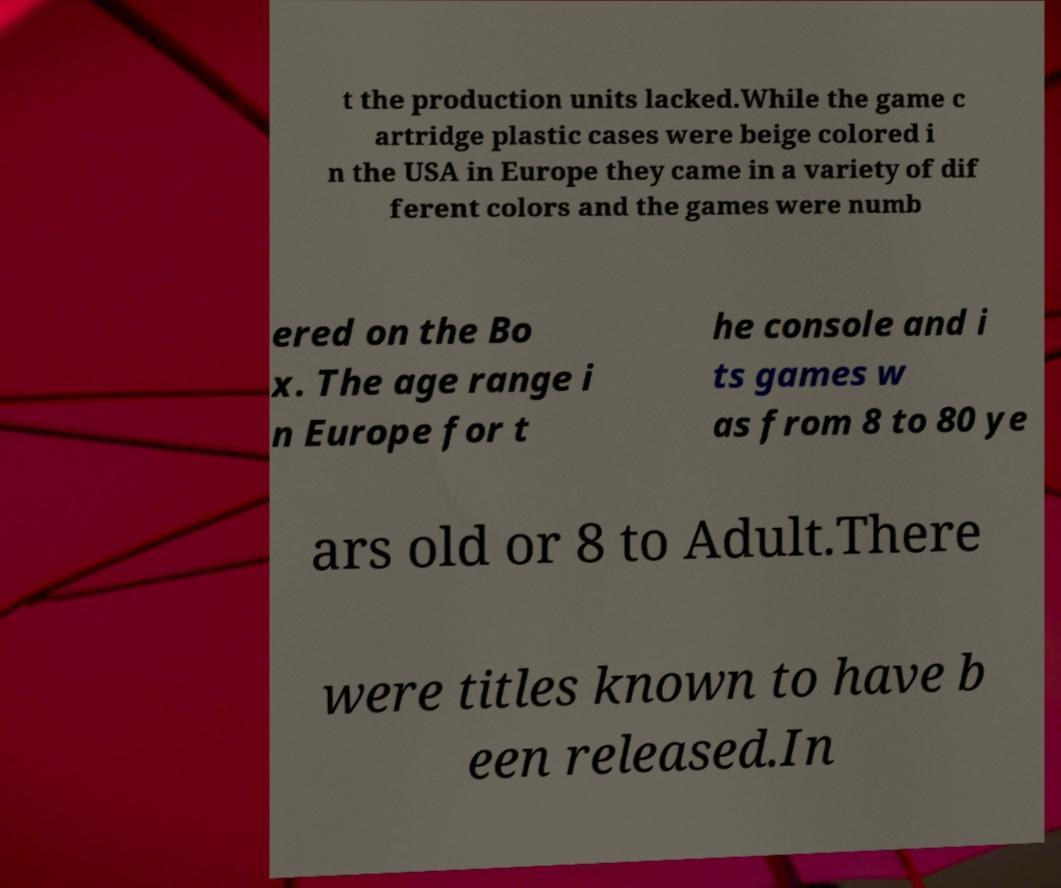What messages or text are displayed in this image? I need them in a readable, typed format. t the production units lacked.While the game c artridge plastic cases were beige colored i n the USA in Europe they came in a variety of dif ferent colors and the games were numb ered on the Bo x. The age range i n Europe for t he console and i ts games w as from 8 to 80 ye ars old or 8 to Adult.There were titles known to have b een released.In 